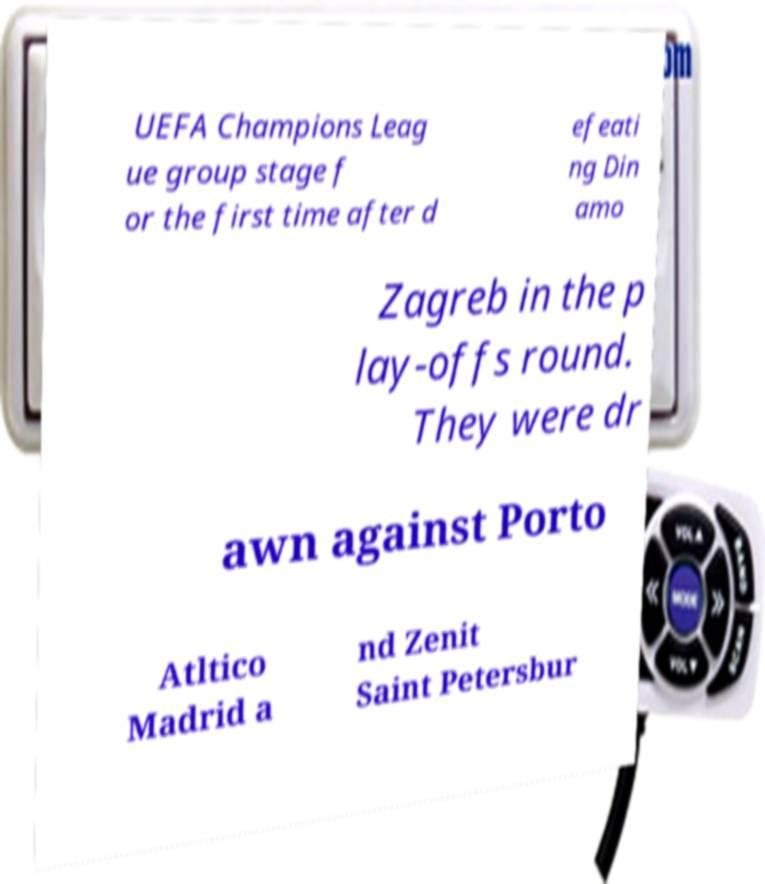Could you assist in decoding the text presented in this image and type it out clearly? UEFA Champions Leag ue group stage f or the first time after d efeati ng Din amo Zagreb in the p lay-offs round. They were dr awn against Porto Atltico Madrid a nd Zenit Saint Petersbur 